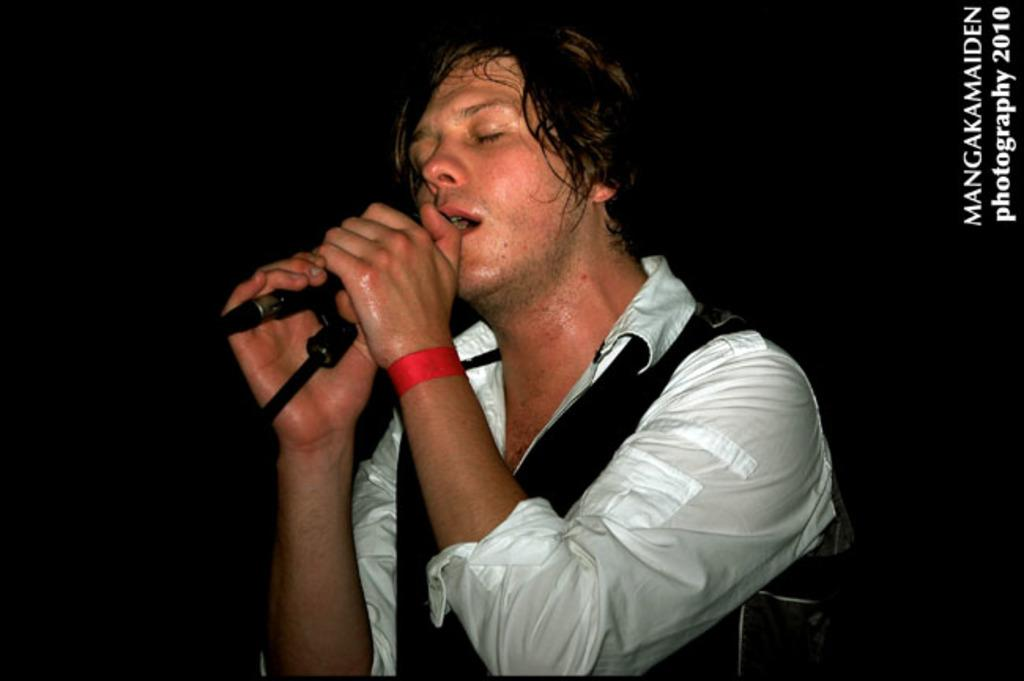What is the main subject of the image? There is a person in the image. What is the person wearing? The person is wearing a white shirt. What object is the person holding? The person is holding a microphone. What activity is the person engaged in? The person is singing. How many pies can be seen on the person's head in the image? There are no pies present in the image; the person is wearing a white shirt and holding a microphone while singing. 